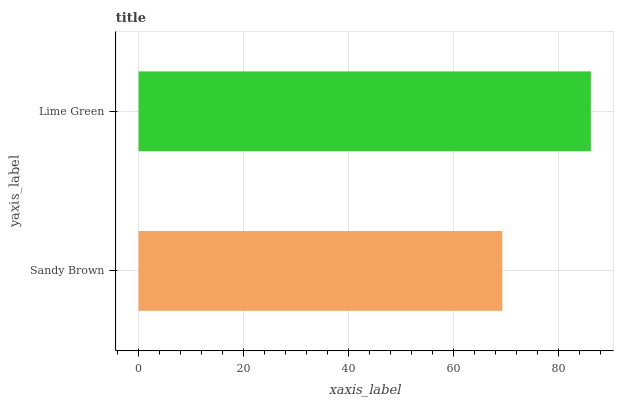Is Sandy Brown the minimum?
Answer yes or no. Yes. Is Lime Green the maximum?
Answer yes or no. Yes. Is Lime Green the minimum?
Answer yes or no. No. Is Lime Green greater than Sandy Brown?
Answer yes or no. Yes. Is Sandy Brown less than Lime Green?
Answer yes or no. Yes. Is Sandy Brown greater than Lime Green?
Answer yes or no. No. Is Lime Green less than Sandy Brown?
Answer yes or no. No. Is Lime Green the high median?
Answer yes or no. Yes. Is Sandy Brown the low median?
Answer yes or no. Yes. Is Sandy Brown the high median?
Answer yes or no. No. Is Lime Green the low median?
Answer yes or no. No. 